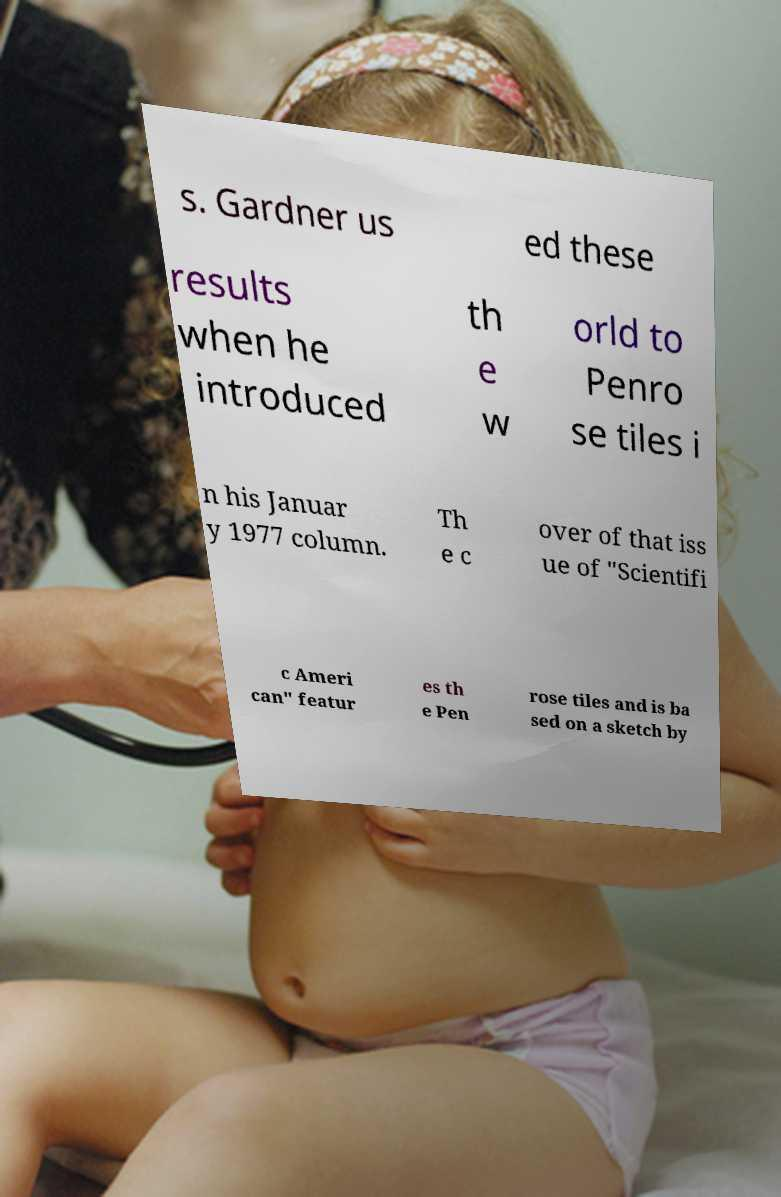Can you accurately transcribe the text from the provided image for me? s. Gardner us ed these results when he introduced th e w orld to Penro se tiles i n his Januar y 1977 column. Th e c over of that iss ue of "Scientifi c Ameri can" featur es th e Pen rose tiles and is ba sed on a sketch by 